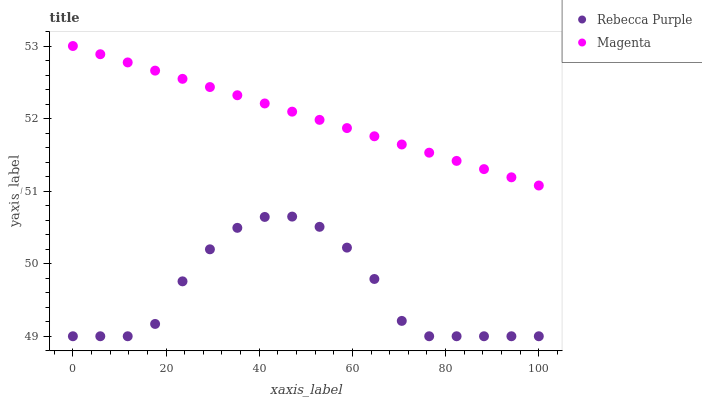Does Rebecca Purple have the minimum area under the curve?
Answer yes or no. Yes. Does Magenta have the maximum area under the curve?
Answer yes or no. Yes. Does Rebecca Purple have the maximum area under the curve?
Answer yes or no. No. Is Magenta the smoothest?
Answer yes or no. Yes. Is Rebecca Purple the roughest?
Answer yes or no. Yes. Is Rebecca Purple the smoothest?
Answer yes or no. No. Does Rebecca Purple have the lowest value?
Answer yes or no. Yes. Does Magenta have the highest value?
Answer yes or no. Yes. Does Rebecca Purple have the highest value?
Answer yes or no. No. Is Rebecca Purple less than Magenta?
Answer yes or no. Yes. Is Magenta greater than Rebecca Purple?
Answer yes or no. Yes. Does Rebecca Purple intersect Magenta?
Answer yes or no. No. 